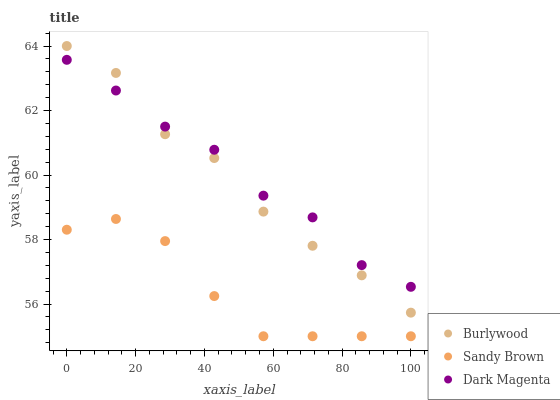Does Sandy Brown have the minimum area under the curve?
Answer yes or no. Yes. Does Dark Magenta have the maximum area under the curve?
Answer yes or no. Yes. Does Dark Magenta have the minimum area under the curve?
Answer yes or no. No. Does Sandy Brown have the maximum area under the curve?
Answer yes or no. No. Is Dark Magenta the smoothest?
Answer yes or no. Yes. Is Burlywood the roughest?
Answer yes or no. Yes. Is Sandy Brown the smoothest?
Answer yes or no. No. Is Sandy Brown the roughest?
Answer yes or no. No. Does Sandy Brown have the lowest value?
Answer yes or no. Yes. Does Dark Magenta have the lowest value?
Answer yes or no. No. Does Burlywood have the highest value?
Answer yes or no. Yes. Does Dark Magenta have the highest value?
Answer yes or no. No. Is Sandy Brown less than Dark Magenta?
Answer yes or no. Yes. Is Burlywood greater than Sandy Brown?
Answer yes or no. Yes. Does Burlywood intersect Dark Magenta?
Answer yes or no. Yes. Is Burlywood less than Dark Magenta?
Answer yes or no. No. Is Burlywood greater than Dark Magenta?
Answer yes or no. No. Does Sandy Brown intersect Dark Magenta?
Answer yes or no. No. 